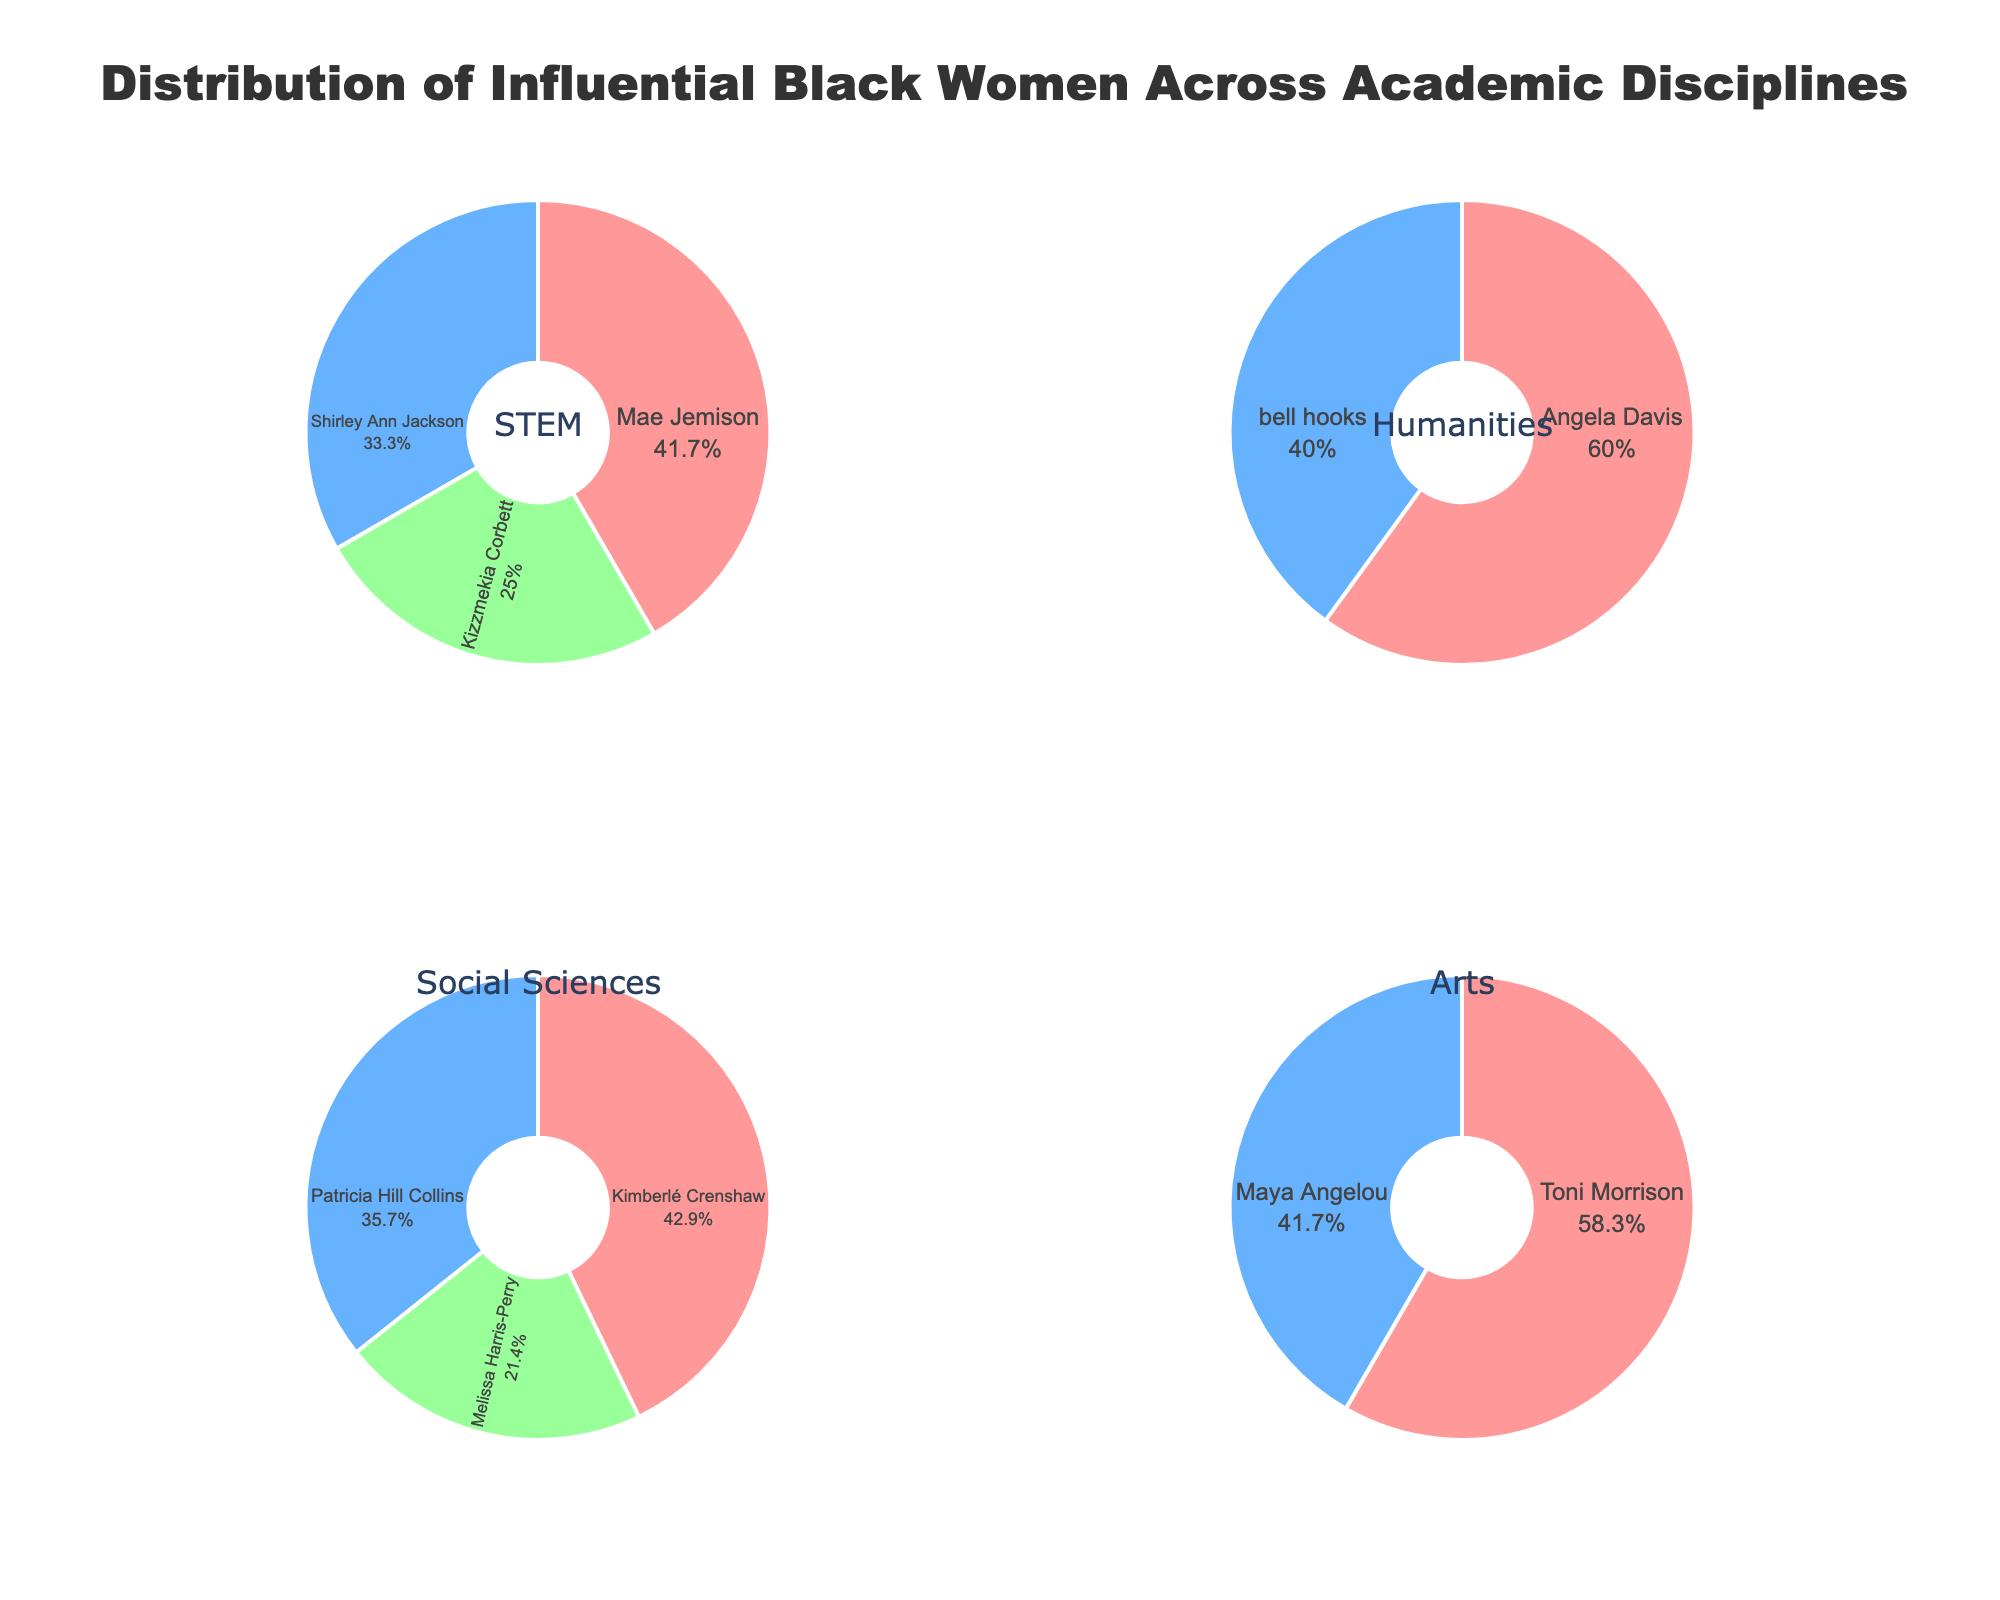What is the title of the figure? The title is displayed at the top of the figure, which gives us overall information on what the figure represents. The title is "Distribution of Influential Black Women Across Academic Disciplines".
Answer: Distribution of Influential Black Women Across Academic Disciplines Which discipline has the highest representation of a single figure? Toni Morrison has the highest representation in the Arts discipline with 35%. This can be seen from the size and labeling of the slices in the pie chart.
Answer: Arts What is the combined percentage of Mae Jemison, Shirley Ann Jackson, and Kizzmekia Corbett in STEM? We need to add the percentages of these figures: Mae Jemison (25%), Shirley Ann Jackson (20%), and Kizzmekia Corbett (15%). 25 + 20 + 15 = 60
Answer: 60% How does Angela Davis's representation in Humanities compare to Patricia Hill Collins's representation in Social Sciences? Angela Davis has 18% representation in Humanities, whereas Patricia Hill Collins has 25% in Social Sciences. Comparing these, 25% is greater than 18%.
Answer: Patricia Hill Collins has a higher representation Which figures are represented in the Social Sciences discipline, and what are their individual percentages? The Social Sciences pie chart includes Kimberlé Crenshaw (30%), Patricia Hill Collins (25%), and Melissa Harris-Perry (15%). This can be seen from the labels and corresponding slices in the Social Sciences pie chart.
Answer: Kimberlé Crenshaw (30%), Patricia Hill Collins (25%), Melissa Harris-Perry (15%) What is the average percentage representation of figures in the Arts discipline? The Arts discipline includes Toni Morrison (35%) and Maya Angelou (25%). Adding these gives 35 + 25 = 60, and there are 2 figures, so 60 / 2 = 30.
Answer: 30% Which discipline has the smallest combined percentage of represented figures? We compare the combined percentages: 
STEM: Mae Jemison (25%) + Shirley Ann Jackson (20%) + Kizzmekia Corbett (15%) = 60%
Humanities: Angela Davis (18%) + bell hooks (12%) = 30%
Social Sciences: Kimberlé Crenshaw (30%) + Patricia Hill Collins (25%) + Melissa Harris-Perry (15%) = 70%
Arts: Toni Morrison (35%) + Maya Angelou (25%) = 60%
Thus, Humanities has the smallest combined percentage of 30%.
Answer: Humanities Who has a higher representation percentage in their respective disciplines: Toni Morrison or Angela Davis? Toni Morrison has 35% in Arts, while Angela Davis has 18% in Humanities. Thus, Toni Morrison's percentage is higher.
Answer: Toni Morrison 